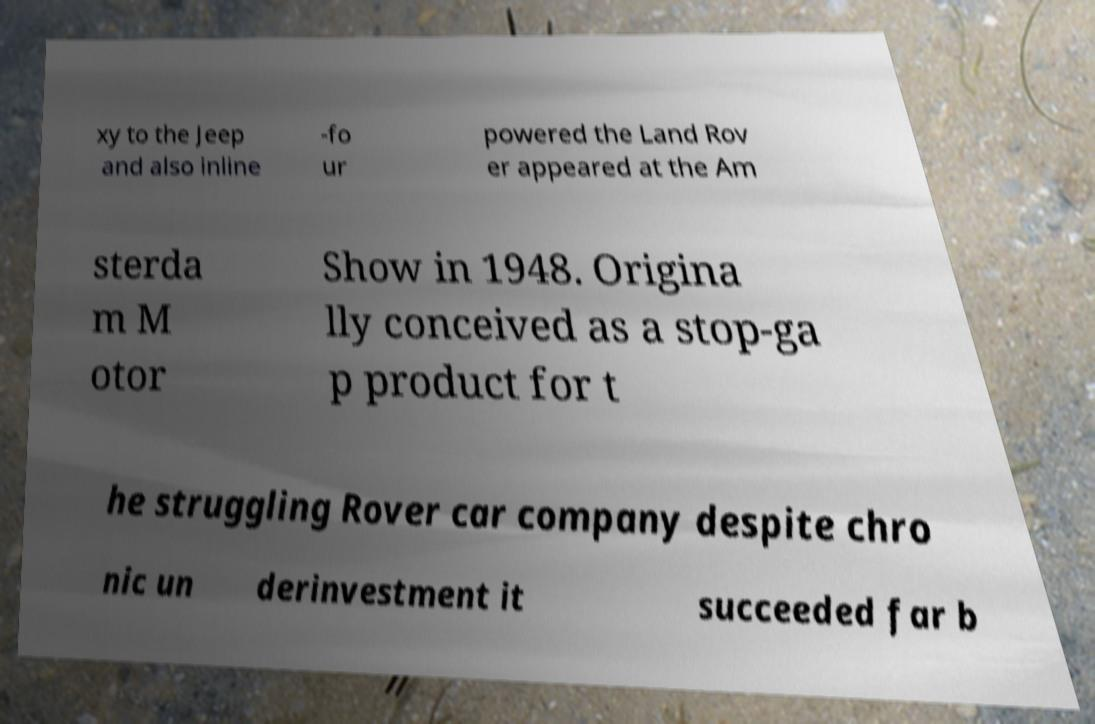Could you extract and type out the text from this image? xy to the Jeep and also inline -fo ur powered the Land Rov er appeared at the Am sterda m M otor Show in 1948. Origina lly conceived as a stop-ga p product for t he struggling Rover car company despite chro nic un derinvestment it succeeded far b 